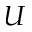<formula> <loc_0><loc_0><loc_500><loc_500>U</formula> 